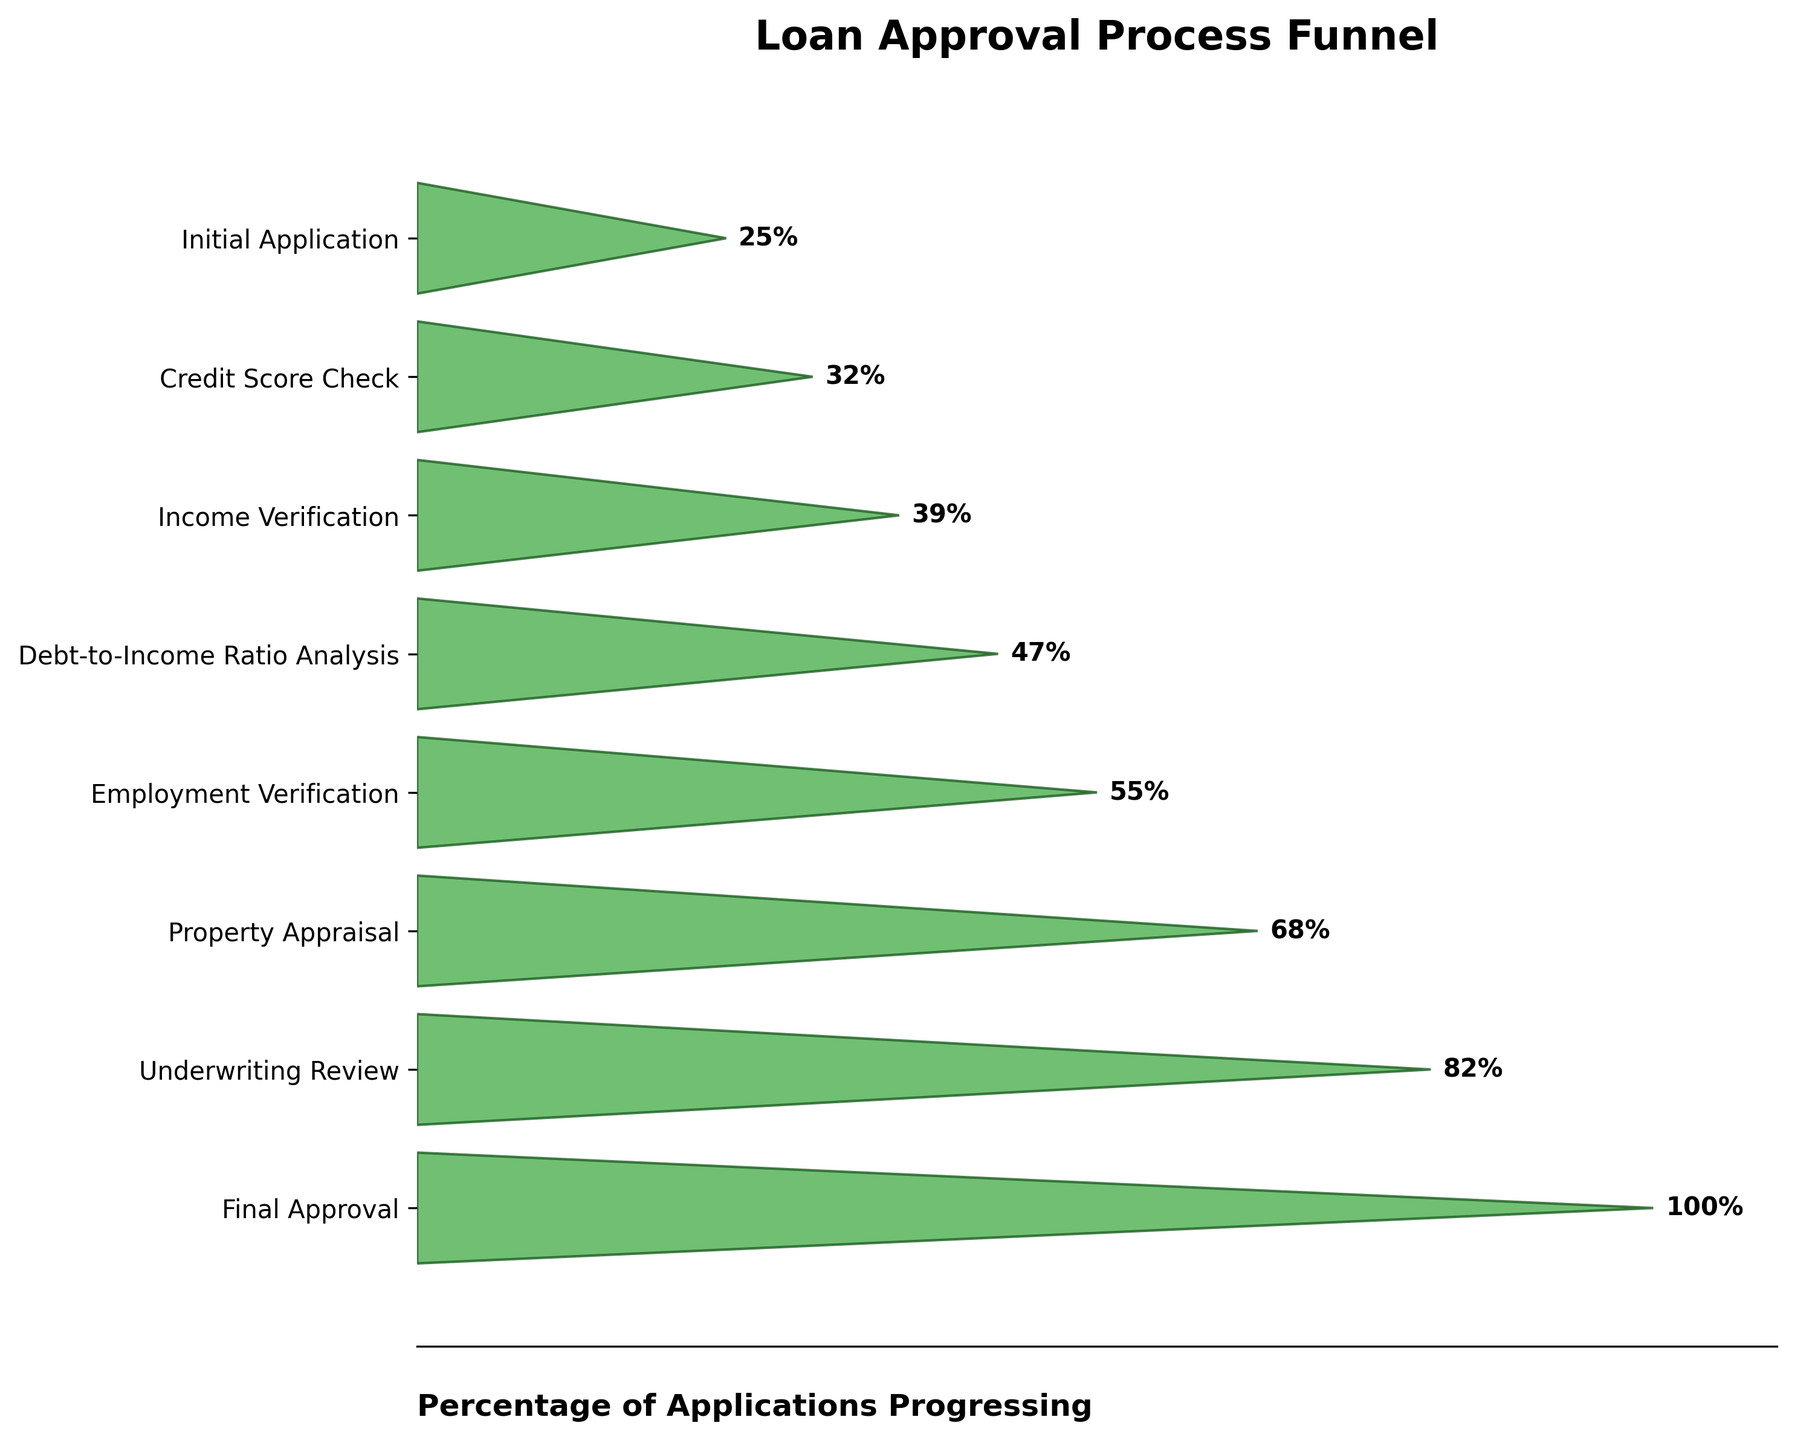What's the title of the funnel chart? The title of the funnel chart is clearly displayed at the top.
Answer: Loan Approval Process Funnel What percentage of applications reach the Final Approval stage? Locate the "Final Approval" stage on the vertical axis and read the corresponding percentage.
Answer: 25% Which stage has the largest drop in percentage from the previous stage? Compare each stage's percentage with the previous one to identify the largest drop. The difference between "Percentage" of "Employment Verification" (47%) and "Property Appraisal" (39%) is 8%, which is the largest.
Answer: Employment Verification to Property Appraisal What is the percentage difference between the Income Verification and Underwriting Review stages? Subtract the percentage of the Underwriting Review stage (32%) from the Income Verification stage (68%). 68% - 32% = 36%.
Answer: 36% How many stages are there in the loan approval process? Count the total number of stages listed in the funnel chart.
Answer: 8 What is the percentage of applications that fail to progress past the Credit Score Check stage? Subtract the percentage of applications that pass the Credit Score Check stage (82%) from the total applications (100%). 100% - 82% = 18%.
Answer: 18% How does the percentage of applications that pass the Property Appraisal stage compare to those that pass the Employment Verification stage? Compare the percentages: Property Appraisal has 39%, and Employment Verification has 47%. 39% is less than 47%.
Answer: Property Appraisal is less than Employment Verification Which stage shows a percentage closest to 50%? Identify the stage with a percentage nearest to 50%. Debt-to-Income Ratio Analysis is 55%, which is the closest to 50%.
Answer: Debt-to-Income Ratio Analysis What is the average percentage of applications that pass through all stages? Sum all the percentages and divide by the number of stages. (100% + 82% + 68% + 55% + 47% + 39% + 32% + 25%) / 8 = 56%.
Answer: 56% What stage follows Property Appraisal in the funnel? Identify the stage that comes immediately after the Property Appraisal stage.
Answer: Underwriting Review 